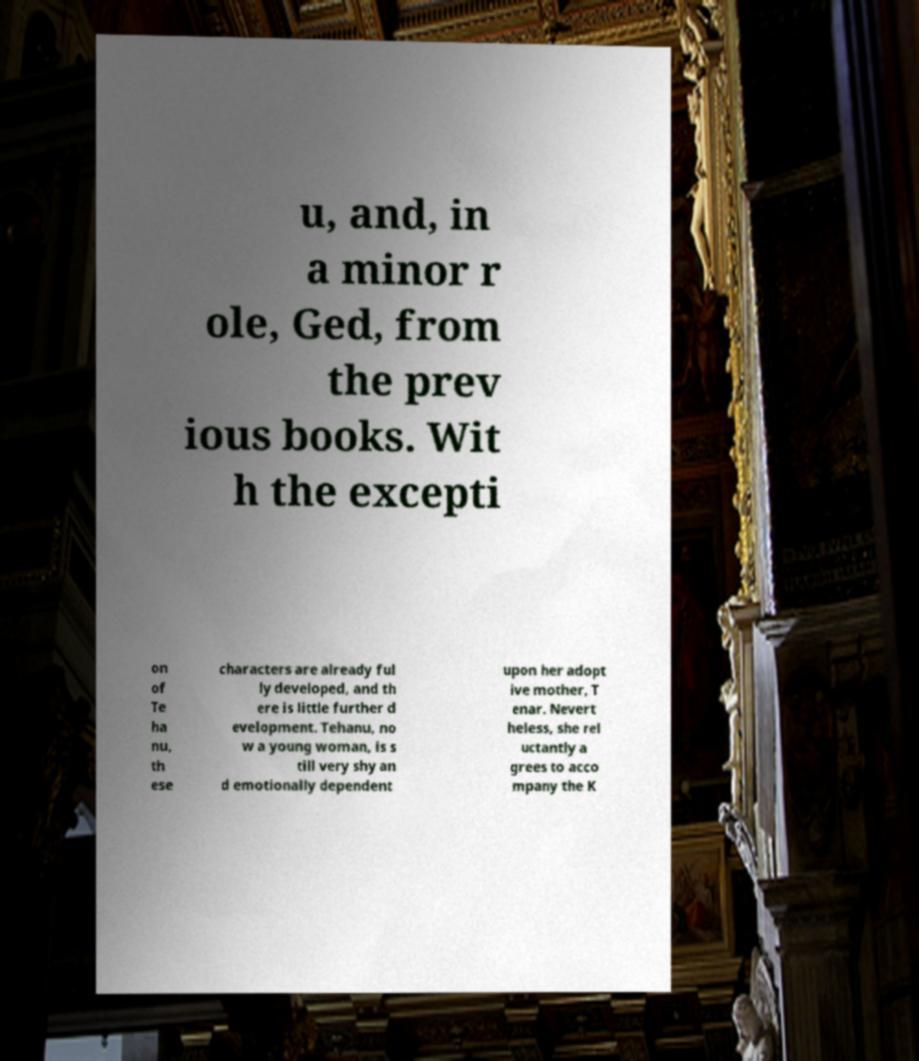For documentation purposes, I need the text within this image transcribed. Could you provide that? u, and, in a minor r ole, Ged, from the prev ious books. Wit h the excepti on of Te ha nu, th ese characters are already ful ly developed, and th ere is little further d evelopment. Tehanu, no w a young woman, is s till very shy an d emotionally dependent upon her adopt ive mother, T enar. Nevert heless, she rel uctantly a grees to acco mpany the K 